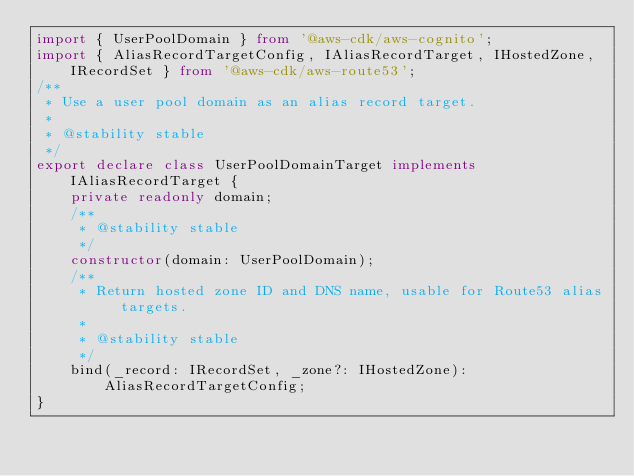<code> <loc_0><loc_0><loc_500><loc_500><_TypeScript_>import { UserPoolDomain } from '@aws-cdk/aws-cognito';
import { AliasRecordTargetConfig, IAliasRecordTarget, IHostedZone, IRecordSet } from '@aws-cdk/aws-route53';
/**
 * Use a user pool domain as an alias record target.
 *
 * @stability stable
 */
export declare class UserPoolDomainTarget implements IAliasRecordTarget {
    private readonly domain;
    /**
     * @stability stable
     */
    constructor(domain: UserPoolDomain);
    /**
     * Return hosted zone ID and DNS name, usable for Route53 alias targets.
     *
     * @stability stable
     */
    bind(_record: IRecordSet, _zone?: IHostedZone): AliasRecordTargetConfig;
}
</code> 